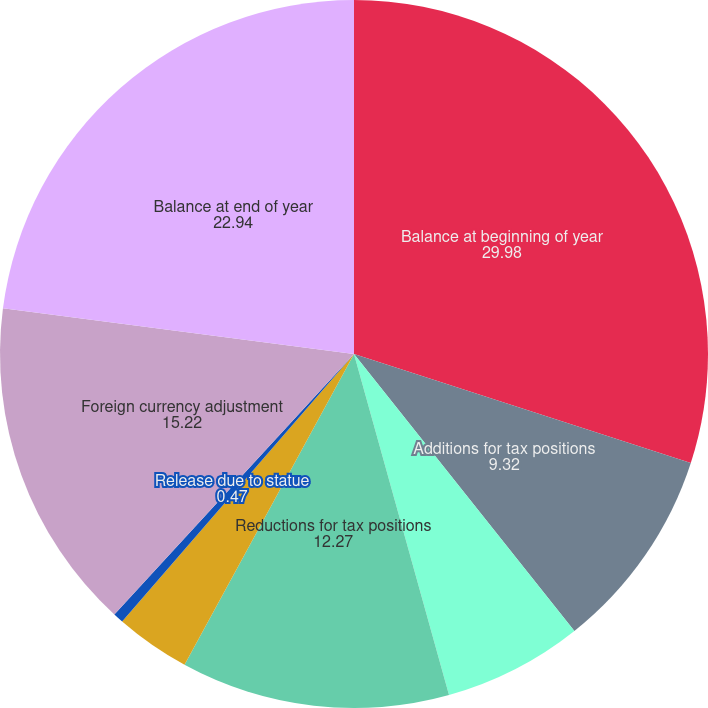Convert chart. <chart><loc_0><loc_0><loc_500><loc_500><pie_chart><fcel>Balance at beginning of year<fcel>Additions for tax positions<fcel>Additions for tax positions of<fcel>Reductions for tax positions<fcel>Settlements<fcel>Release due to statue<fcel>Foreign currency adjustment<fcel>Balance at end of year<nl><fcel>29.98%<fcel>9.32%<fcel>6.37%<fcel>12.27%<fcel>3.42%<fcel>0.47%<fcel>15.22%<fcel>22.94%<nl></chart> 